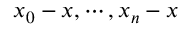<formula> <loc_0><loc_0><loc_500><loc_500>x _ { 0 } - x , \cdots , x _ { n } - x</formula> 